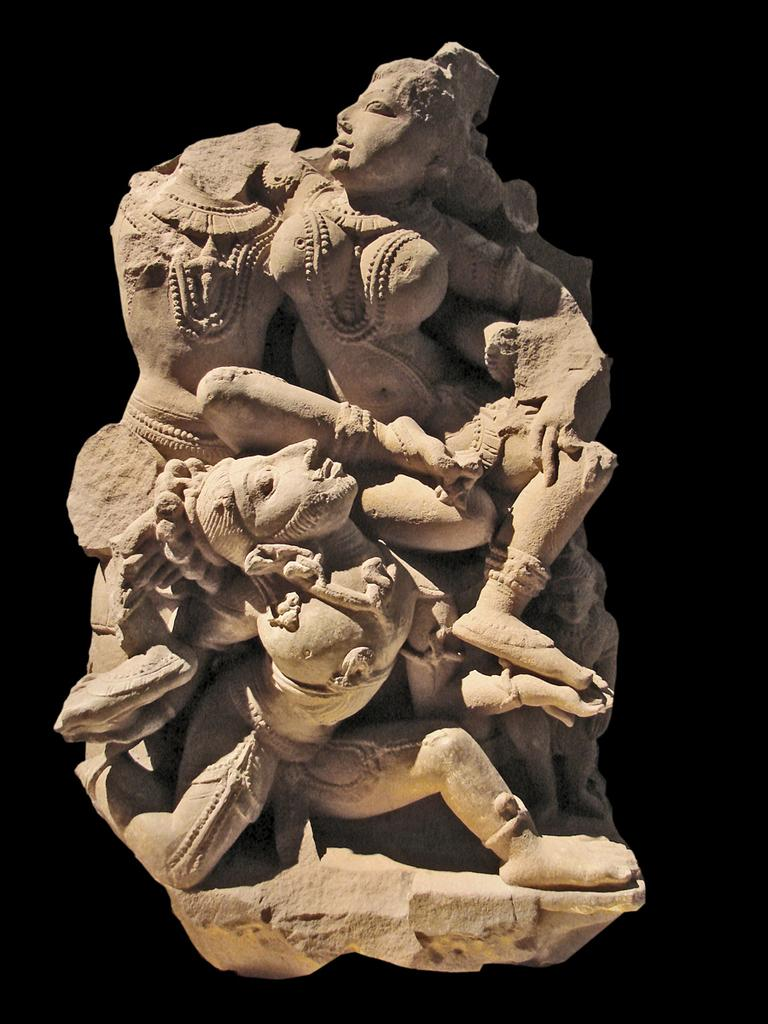What is the main subject in the center of the image? There is a sculpture in the center of the image. How does the sculpture express anger in the image? The sculpture does not express anger in the image, as it is an inanimate object and cannot display emotions. 